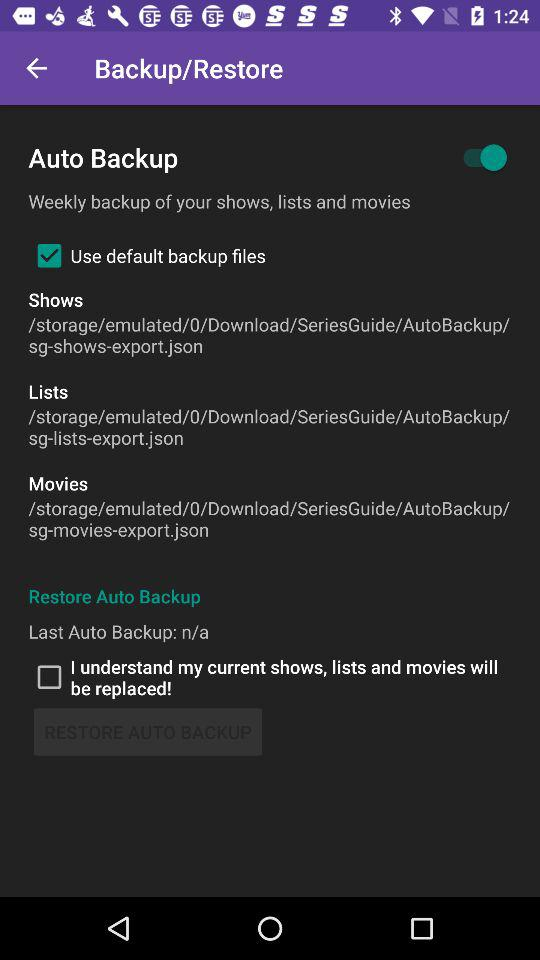When was last auto backup taken?
When the provided information is insufficient, respond with <no answer>. <no answer> 